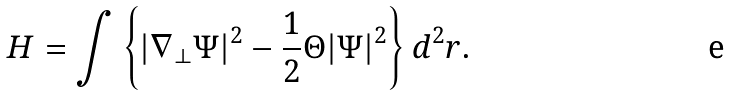Convert formula to latex. <formula><loc_0><loc_0><loc_500><loc_500>H = \int \left \{ | \nabla _ { \perp } \Psi | ^ { 2 } - \frac { 1 } { 2 } \Theta | \Psi | ^ { 2 } \right \} d ^ { 2 } r .</formula> 